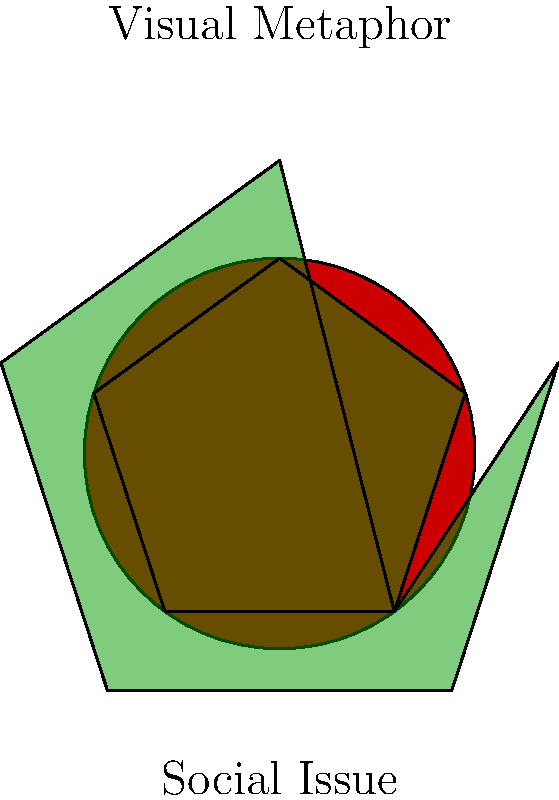In film posters addressing social issues, how does the use of visual metaphors contribute to provoking important discussions, and what elements should you look for when analyzing such posters? 1. Understand the purpose of visual metaphors in film posters:
   - They convey complex ideas through simple imagery
   - They engage viewers emotionally and intellectually

2. Recognize common elements of visual metaphors in social issue film posters:
   - Symbolic objects or figures
   - Contrasting colors or shapes
   - Unexpected juxtapositions

3. Analyze the relationship between the visual metaphor and the social issue:
   - How does the imagery represent the problem?
   - What emotions does it evoke?

4. Consider the impact on provoking discussions:
   - Visual metaphors can make abstract issues more tangible
   - They can challenge viewers' perspectives
   - They can spark curiosity and encourage further exploration of the topic

5. Look for specific elements when analyzing posters:
   - Central imagery and its symbolic meaning
   - Color schemes and their emotional associations
   - Text placement and interaction with visuals
   - Overall composition and focal points

6. Reflect on how the visual metaphor aligns with the director's intention:
   - Does it effectively communicate the film's message?
   - How might it resonate with different audiences?

7. Consider how the poster might inspire conversations:
   - What questions does it raise?
   - How might it challenge societal norms or beliefs?
Answer: Visual metaphors in film posters use symbolic imagery to represent complex social issues, evoking emotions and sparking discussions by making abstract concepts more tangible and thought-provoking. 